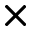Convert formula to latex. <formula><loc_0><loc_0><loc_500><loc_500>\times</formula> 